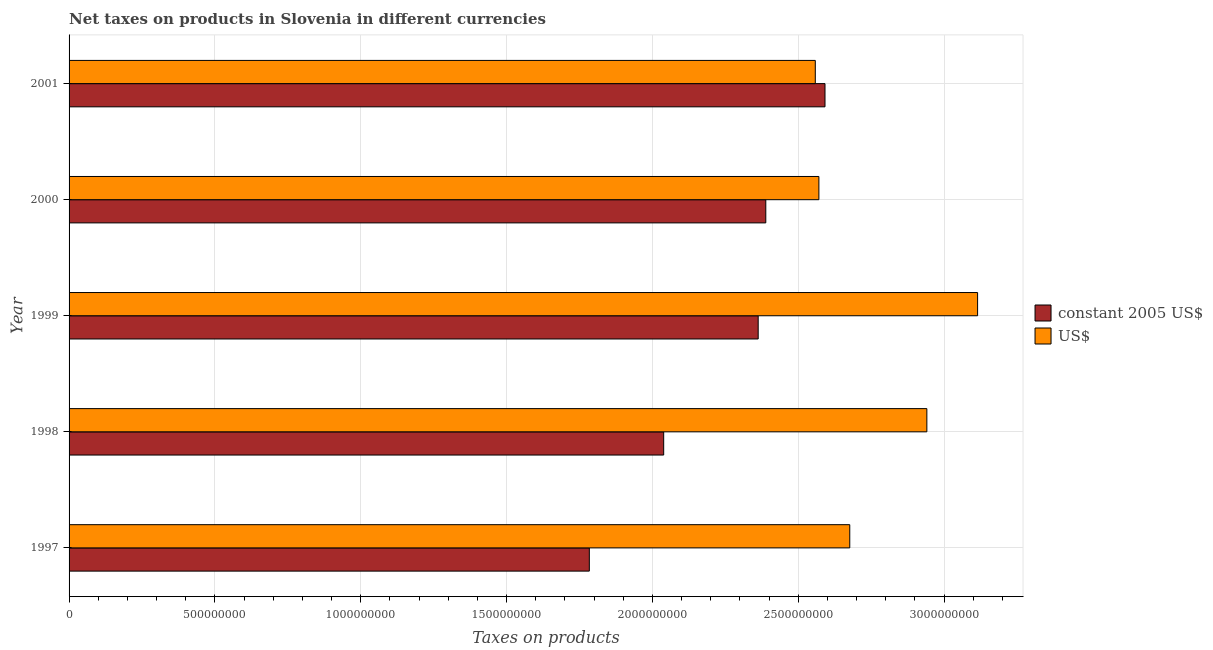How many different coloured bars are there?
Your answer should be compact. 2. How many bars are there on the 4th tick from the top?
Offer a very short reply. 2. How many bars are there on the 2nd tick from the bottom?
Offer a terse response. 2. What is the net taxes in us$ in 1999?
Your answer should be compact. 3.12e+09. Across all years, what is the maximum net taxes in constant 2005 us$?
Ensure brevity in your answer.  2.59e+09. Across all years, what is the minimum net taxes in us$?
Provide a succinct answer. 2.56e+09. In which year was the net taxes in constant 2005 us$ maximum?
Offer a terse response. 2001. What is the total net taxes in us$ in the graph?
Your answer should be very brief. 1.39e+1. What is the difference between the net taxes in us$ in 1997 and that in 1999?
Provide a succinct answer. -4.38e+08. What is the difference between the net taxes in us$ in 1999 and the net taxes in constant 2005 us$ in 2001?
Ensure brevity in your answer.  5.23e+08. What is the average net taxes in constant 2005 us$ per year?
Provide a short and direct response. 2.23e+09. In the year 2000, what is the difference between the net taxes in us$ and net taxes in constant 2005 us$?
Keep it short and to the point. 1.82e+08. What is the ratio of the net taxes in constant 2005 us$ in 1997 to that in 2001?
Your answer should be very brief. 0.69. Is the difference between the net taxes in constant 2005 us$ in 1998 and 2001 greater than the difference between the net taxes in us$ in 1998 and 2001?
Make the answer very short. No. What is the difference between the highest and the second highest net taxes in us$?
Your response must be concise. 1.74e+08. What is the difference between the highest and the lowest net taxes in us$?
Make the answer very short. 5.56e+08. In how many years, is the net taxes in us$ greater than the average net taxes in us$ taken over all years?
Your answer should be compact. 2. Is the sum of the net taxes in constant 2005 us$ in 2000 and 2001 greater than the maximum net taxes in us$ across all years?
Your answer should be very brief. Yes. What does the 2nd bar from the top in 2000 represents?
Offer a terse response. Constant 2005 us$. What does the 2nd bar from the bottom in 1999 represents?
Give a very brief answer. US$. Are all the bars in the graph horizontal?
Your response must be concise. Yes. What is the difference between two consecutive major ticks on the X-axis?
Ensure brevity in your answer.  5.00e+08. Where does the legend appear in the graph?
Provide a short and direct response. Center right. How many legend labels are there?
Provide a succinct answer. 2. How are the legend labels stacked?
Keep it short and to the point. Vertical. What is the title of the graph?
Offer a terse response. Net taxes on products in Slovenia in different currencies. Does "Official aid received" appear as one of the legend labels in the graph?
Keep it short and to the point. No. What is the label or title of the X-axis?
Ensure brevity in your answer.  Taxes on products. What is the Taxes on products of constant 2005 US$ in 1997?
Your answer should be compact. 1.78e+09. What is the Taxes on products in US$ in 1997?
Provide a short and direct response. 2.68e+09. What is the Taxes on products in constant 2005 US$ in 1998?
Your answer should be very brief. 2.04e+09. What is the Taxes on products in US$ in 1998?
Your answer should be compact. 2.94e+09. What is the Taxes on products of constant 2005 US$ in 1999?
Make the answer very short. 2.36e+09. What is the Taxes on products in US$ in 1999?
Provide a succinct answer. 3.12e+09. What is the Taxes on products in constant 2005 US$ in 2000?
Your answer should be compact. 2.39e+09. What is the Taxes on products in US$ in 2000?
Provide a short and direct response. 2.57e+09. What is the Taxes on products of constant 2005 US$ in 2001?
Your response must be concise. 2.59e+09. What is the Taxes on products in US$ in 2001?
Give a very brief answer. 2.56e+09. Across all years, what is the maximum Taxes on products of constant 2005 US$?
Provide a succinct answer. 2.59e+09. Across all years, what is the maximum Taxes on products of US$?
Give a very brief answer. 3.12e+09. Across all years, what is the minimum Taxes on products in constant 2005 US$?
Ensure brevity in your answer.  1.78e+09. Across all years, what is the minimum Taxes on products in US$?
Your answer should be compact. 2.56e+09. What is the total Taxes on products in constant 2005 US$ in the graph?
Keep it short and to the point. 1.12e+1. What is the total Taxes on products in US$ in the graph?
Ensure brevity in your answer.  1.39e+1. What is the difference between the Taxes on products of constant 2005 US$ in 1997 and that in 1998?
Give a very brief answer. -2.55e+08. What is the difference between the Taxes on products of US$ in 1997 and that in 1998?
Make the answer very short. -2.64e+08. What is the difference between the Taxes on products of constant 2005 US$ in 1997 and that in 1999?
Keep it short and to the point. -5.79e+08. What is the difference between the Taxes on products in US$ in 1997 and that in 1999?
Your answer should be very brief. -4.38e+08. What is the difference between the Taxes on products in constant 2005 US$ in 1997 and that in 2000?
Your response must be concise. -6.05e+08. What is the difference between the Taxes on products of US$ in 1997 and that in 2000?
Keep it short and to the point. 1.06e+08. What is the difference between the Taxes on products in constant 2005 US$ in 1997 and that in 2001?
Your response must be concise. -8.08e+08. What is the difference between the Taxes on products of US$ in 1997 and that in 2001?
Your answer should be compact. 1.18e+08. What is the difference between the Taxes on products in constant 2005 US$ in 1998 and that in 1999?
Offer a very short reply. -3.24e+08. What is the difference between the Taxes on products of US$ in 1998 and that in 1999?
Your answer should be very brief. -1.74e+08. What is the difference between the Taxes on products in constant 2005 US$ in 1998 and that in 2000?
Your response must be concise. -3.50e+08. What is the difference between the Taxes on products in US$ in 1998 and that in 2000?
Your answer should be compact. 3.70e+08. What is the difference between the Taxes on products of constant 2005 US$ in 1998 and that in 2001?
Offer a terse response. -5.53e+08. What is the difference between the Taxes on products in US$ in 1998 and that in 2001?
Offer a very short reply. 3.83e+08. What is the difference between the Taxes on products of constant 2005 US$ in 1999 and that in 2000?
Offer a terse response. -2.61e+07. What is the difference between the Taxes on products in US$ in 1999 and that in 2000?
Your answer should be compact. 5.44e+08. What is the difference between the Taxes on products of constant 2005 US$ in 1999 and that in 2001?
Offer a very short reply. -2.29e+08. What is the difference between the Taxes on products of US$ in 1999 and that in 2001?
Your answer should be very brief. 5.56e+08. What is the difference between the Taxes on products in constant 2005 US$ in 2000 and that in 2001?
Offer a terse response. -2.03e+08. What is the difference between the Taxes on products in US$ in 2000 and that in 2001?
Offer a very short reply. 1.23e+07. What is the difference between the Taxes on products of constant 2005 US$ in 1997 and the Taxes on products of US$ in 1998?
Keep it short and to the point. -1.16e+09. What is the difference between the Taxes on products of constant 2005 US$ in 1997 and the Taxes on products of US$ in 1999?
Your response must be concise. -1.33e+09. What is the difference between the Taxes on products in constant 2005 US$ in 1997 and the Taxes on products in US$ in 2000?
Make the answer very short. -7.87e+08. What is the difference between the Taxes on products in constant 2005 US$ in 1997 and the Taxes on products in US$ in 2001?
Your response must be concise. -7.75e+08. What is the difference between the Taxes on products in constant 2005 US$ in 1998 and the Taxes on products in US$ in 1999?
Keep it short and to the point. -1.08e+09. What is the difference between the Taxes on products of constant 2005 US$ in 1998 and the Taxes on products of US$ in 2000?
Your answer should be very brief. -5.32e+08. What is the difference between the Taxes on products of constant 2005 US$ in 1998 and the Taxes on products of US$ in 2001?
Offer a very short reply. -5.20e+08. What is the difference between the Taxes on products of constant 2005 US$ in 1999 and the Taxes on products of US$ in 2000?
Provide a short and direct response. -2.08e+08. What is the difference between the Taxes on products of constant 2005 US$ in 1999 and the Taxes on products of US$ in 2001?
Offer a terse response. -1.96e+08. What is the difference between the Taxes on products of constant 2005 US$ in 2000 and the Taxes on products of US$ in 2001?
Offer a very short reply. -1.70e+08. What is the average Taxes on products in constant 2005 US$ per year?
Your answer should be very brief. 2.23e+09. What is the average Taxes on products of US$ per year?
Keep it short and to the point. 2.77e+09. In the year 1997, what is the difference between the Taxes on products in constant 2005 US$ and Taxes on products in US$?
Your answer should be very brief. -8.93e+08. In the year 1998, what is the difference between the Taxes on products of constant 2005 US$ and Taxes on products of US$?
Ensure brevity in your answer.  -9.02e+08. In the year 1999, what is the difference between the Taxes on products in constant 2005 US$ and Taxes on products in US$?
Offer a very short reply. -7.52e+08. In the year 2000, what is the difference between the Taxes on products in constant 2005 US$ and Taxes on products in US$?
Give a very brief answer. -1.82e+08. In the year 2001, what is the difference between the Taxes on products of constant 2005 US$ and Taxes on products of US$?
Your answer should be compact. 3.33e+07. What is the ratio of the Taxes on products of constant 2005 US$ in 1997 to that in 1998?
Provide a succinct answer. 0.87. What is the ratio of the Taxes on products of US$ in 1997 to that in 1998?
Your answer should be compact. 0.91. What is the ratio of the Taxes on products in constant 2005 US$ in 1997 to that in 1999?
Your answer should be compact. 0.76. What is the ratio of the Taxes on products of US$ in 1997 to that in 1999?
Keep it short and to the point. 0.86. What is the ratio of the Taxes on products of constant 2005 US$ in 1997 to that in 2000?
Your answer should be compact. 0.75. What is the ratio of the Taxes on products of US$ in 1997 to that in 2000?
Your answer should be very brief. 1.04. What is the ratio of the Taxes on products of constant 2005 US$ in 1997 to that in 2001?
Your answer should be very brief. 0.69. What is the ratio of the Taxes on products of US$ in 1997 to that in 2001?
Offer a terse response. 1.05. What is the ratio of the Taxes on products in constant 2005 US$ in 1998 to that in 1999?
Offer a terse response. 0.86. What is the ratio of the Taxes on products of US$ in 1998 to that in 1999?
Provide a short and direct response. 0.94. What is the ratio of the Taxes on products in constant 2005 US$ in 1998 to that in 2000?
Offer a terse response. 0.85. What is the ratio of the Taxes on products in US$ in 1998 to that in 2000?
Provide a short and direct response. 1.14. What is the ratio of the Taxes on products of constant 2005 US$ in 1998 to that in 2001?
Offer a very short reply. 0.79. What is the ratio of the Taxes on products in US$ in 1998 to that in 2001?
Your answer should be compact. 1.15. What is the ratio of the Taxes on products of constant 2005 US$ in 1999 to that in 2000?
Give a very brief answer. 0.99. What is the ratio of the Taxes on products of US$ in 1999 to that in 2000?
Your answer should be compact. 1.21. What is the ratio of the Taxes on products of constant 2005 US$ in 1999 to that in 2001?
Keep it short and to the point. 0.91. What is the ratio of the Taxes on products in US$ in 1999 to that in 2001?
Provide a succinct answer. 1.22. What is the ratio of the Taxes on products in constant 2005 US$ in 2000 to that in 2001?
Give a very brief answer. 0.92. What is the ratio of the Taxes on products in US$ in 2000 to that in 2001?
Your answer should be very brief. 1. What is the difference between the highest and the second highest Taxes on products in constant 2005 US$?
Provide a succinct answer. 2.03e+08. What is the difference between the highest and the second highest Taxes on products in US$?
Make the answer very short. 1.74e+08. What is the difference between the highest and the lowest Taxes on products of constant 2005 US$?
Make the answer very short. 8.08e+08. What is the difference between the highest and the lowest Taxes on products of US$?
Offer a terse response. 5.56e+08. 